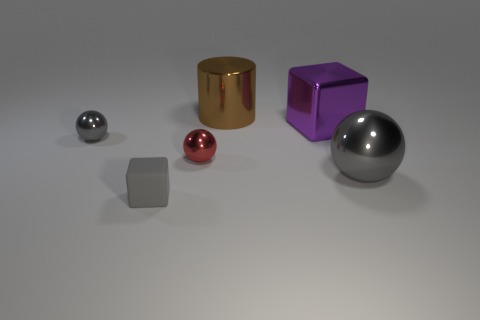What is the material of the tiny ball that is the same color as the tiny matte object? Based on the appearance in the image, the tiny ball that shares the same color as the tiny matte object, which is red, seems to be made of a polished metal. The reflective surface suggests a metallic composition, distinct from the matte finish of the small cube. 